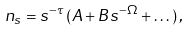<formula> <loc_0><loc_0><loc_500><loc_500>n _ { s } = s ^ { - \tau } \, ( A + B s ^ { - \Omega } + \dots ) \, ,</formula> 